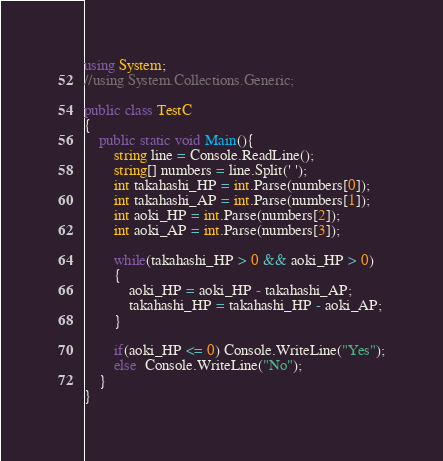Convert code to text. <code><loc_0><loc_0><loc_500><loc_500><_C#_>using System;
//using System.Collections.Generic;

public class TestC
{
    public static void Main(){
        string line = Console.ReadLine();
        string[] numbers = line.Split(' ');
        int takahashi_HP = int.Parse(numbers[0]);
        int takahashi_AP = int.Parse(numbers[1]); 
        int aoki_HP = int.Parse(numbers[2]);
        int aoki_AP = int.Parse(numbers[3]); 

        while(takahashi_HP > 0 && aoki_HP > 0)
        {
            aoki_HP = aoki_HP - takahashi_AP;
            takahashi_HP = takahashi_HP - aoki_AP;
        }

        if(aoki_HP <= 0) Console.WriteLine("Yes");
        else  Console.WriteLine("No");
    }
}</code> 